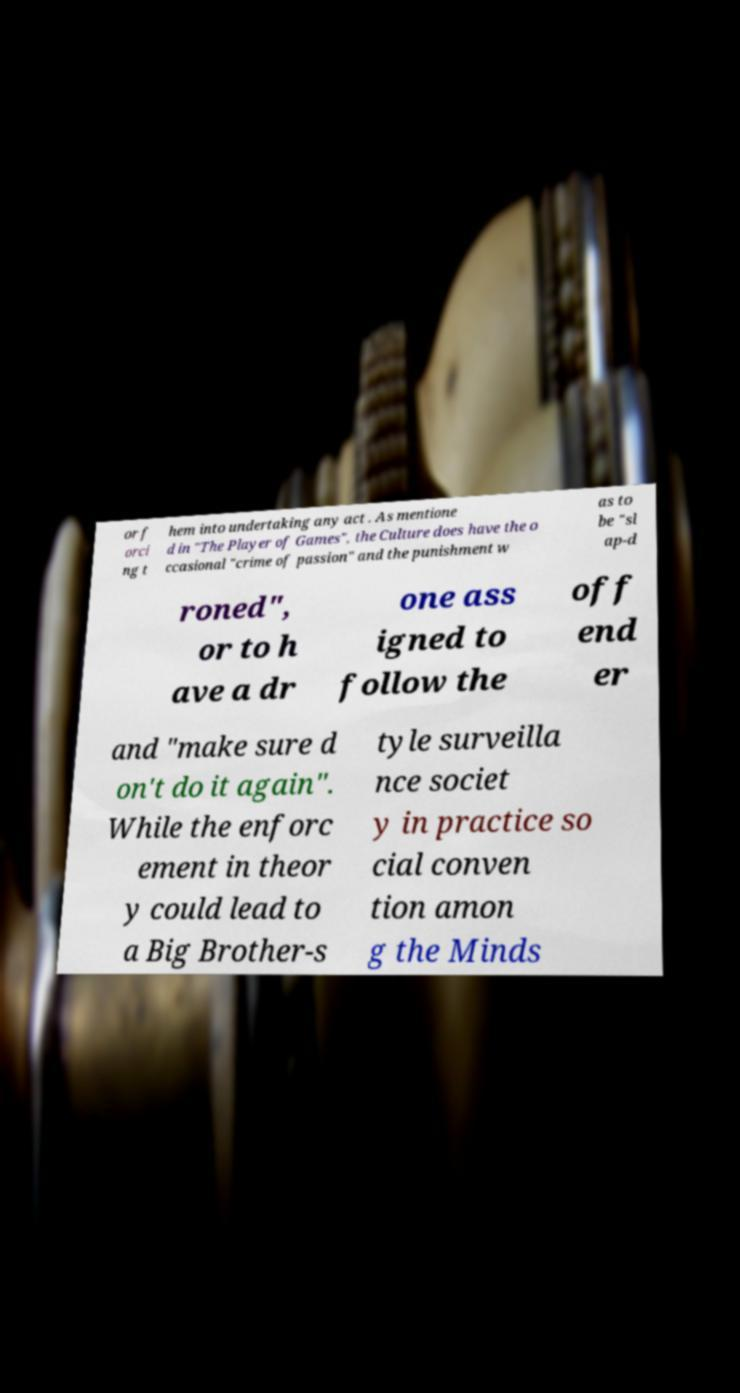What messages or text are displayed in this image? I need them in a readable, typed format. or f orci ng t hem into undertaking any act . As mentione d in "The Player of Games", the Culture does have the o ccasional "crime of passion" and the punishment w as to be "sl ap-d roned", or to h ave a dr one ass igned to follow the off end er and "make sure d on't do it again". While the enforc ement in theor y could lead to a Big Brother-s tyle surveilla nce societ y in practice so cial conven tion amon g the Minds 